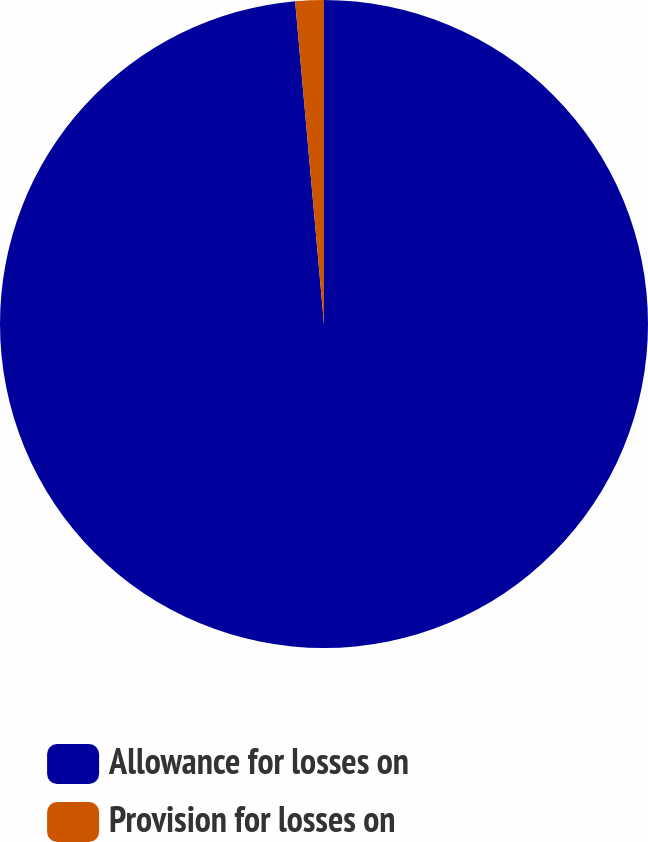Convert chart to OTSL. <chart><loc_0><loc_0><loc_500><loc_500><pie_chart><fcel>Allowance for losses on<fcel>Provision for losses on<nl><fcel>98.58%<fcel>1.42%<nl></chart> 